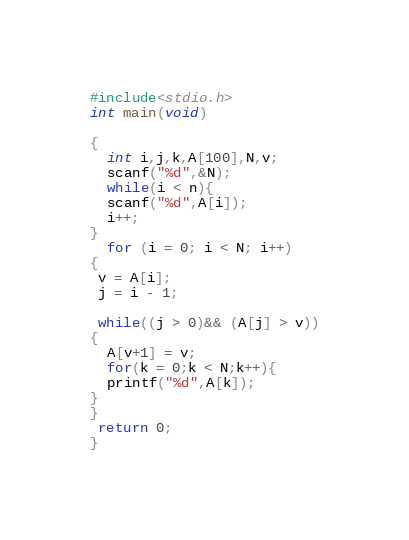Convert code to text. <code><loc_0><loc_0><loc_500><loc_500><_C_>#include<stdio.h>
int main(void)

{
  int i,j,k,A[100],N,v;
  scanf("%d",&N);
  while(i < n){
  scanf("%d",A[i]);
  i++;
}
  for (i = 0; i < N; i++)
{
 v = A[i];
 j = i - 1;

 while((j > 0)&& (A[j] > v))
{
  A[v+1] = v;
  for(k = 0;k < N;k++){
  printf("%d",A[k]);
} 
}
 return 0;
}</code> 